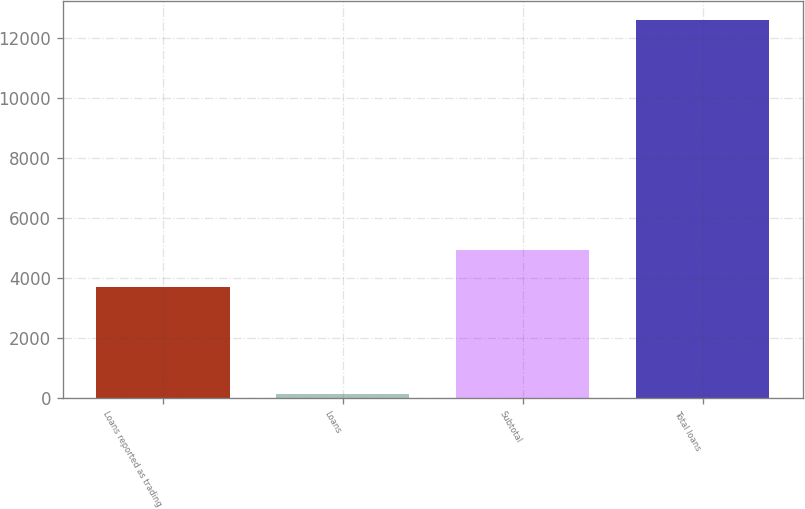Convert chart to OTSL. <chart><loc_0><loc_0><loc_500><loc_500><bar_chart><fcel>Loans reported as trading<fcel>Loans<fcel>Subtotal<fcel>Total loans<nl><fcel>3696<fcel>138<fcel>4941.5<fcel>12593<nl></chart> 